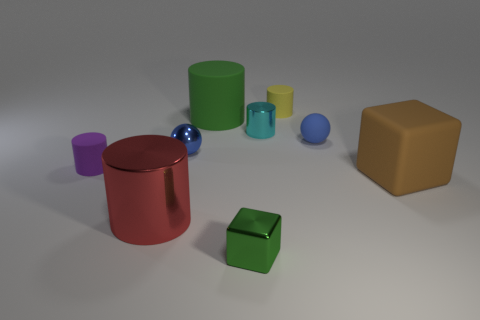What color is the big cylinder in front of the tiny blue ball that is on the right side of the big green rubber object?
Give a very brief answer. Red. What is the size of the sphere on the right side of the cube that is in front of the rubber block?
Provide a short and direct response. Small. What size is the rubber cylinder that is the same color as the tiny metallic block?
Give a very brief answer. Large. What number of other objects are there of the same size as the brown object?
Give a very brief answer. 2. What color is the big cylinder that is behind the brown block in front of the blue object left of the green matte cylinder?
Your response must be concise. Green. What number of other things are there of the same shape as the cyan thing?
Offer a very short reply. 4. What shape is the object to the right of the blue rubber sphere?
Offer a terse response. Cube. Is there a green thing behind the rubber cylinder on the left side of the big metal cylinder?
Make the answer very short. Yes. What color is the rubber thing that is both in front of the matte sphere and on the right side of the green metallic object?
Ensure brevity in your answer.  Brown. Is there a big thing left of the small ball that is right of the tiny object in front of the tiny purple matte cylinder?
Make the answer very short. Yes. 